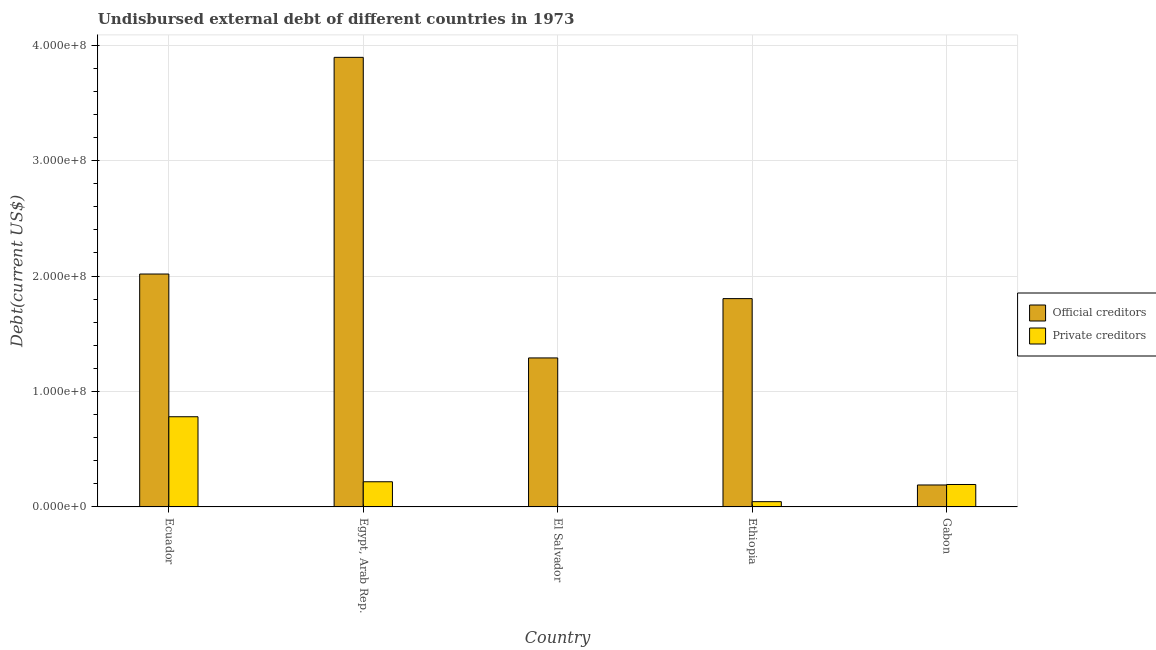How many different coloured bars are there?
Keep it short and to the point. 2. How many groups of bars are there?
Provide a short and direct response. 5. Are the number of bars per tick equal to the number of legend labels?
Your answer should be compact. Yes. Are the number of bars on each tick of the X-axis equal?
Offer a very short reply. Yes. How many bars are there on the 1st tick from the left?
Provide a succinct answer. 2. What is the label of the 2nd group of bars from the left?
Ensure brevity in your answer.  Egypt, Arab Rep. In how many cases, is the number of bars for a given country not equal to the number of legend labels?
Your response must be concise. 0. What is the undisbursed external debt of official creditors in Ecuador?
Provide a succinct answer. 2.02e+08. Across all countries, what is the maximum undisbursed external debt of official creditors?
Ensure brevity in your answer.  3.89e+08. In which country was the undisbursed external debt of official creditors maximum?
Your response must be concise. Egypt, Arab Rep. In which country was the undisbursed external debt of official creditors minimum?
Ensure brevity in your answer.  Gabon. What is the total undisbursed external debt of private creditors in the graph?
Ensure brevity in your answer.  1.24e+08. What is the difference between the undisbursed external debt of official creditors in Ecuador and that in Ethiopia?
Provide a short and direct response. 2.13e+07. What is the difference between the undisbursed external debt of private creditors in El Salvador and the undisbursed external debt of official creditors in Ethiopia?
Provide a succinct answer. -1.80e+08. What is the average undisbursed external debt of private creditors per country?
Provide a short and direct response. 2.48e+07. What is the difference between the undisbursed external debt of official creditors and undisbursed external debt of private creditors in Egypt, Arab Rep.?
Your response must be concise. 3.68e+08. What is the ratio of the undisbursed external debt of official creditors in Ecuador to that in Egypt, Arab Rep.?
Your response must be concise. 0.52. Is the undisbursed external debt of private creditors in Ecuador less than that in El Salvador?
Make the answer very short. No. Is the difference between the undisbursed external debt of official creditors in Ecuador and El Salvador greater than the difference between the undisbursed external debt of private creditors in Ecuador and El Salvador?
Your response must be concise. No. What is the difference between the highest and the second highest undisbursed external debt of private creditors?
Your response must be concise. 5.63e+07. What is the difference between the highest and the lowest undisbursed external debt of official creditors?
Offer a very short reply. 3.70e+08. Is the sum of the undisbursed external debt of official creditors in Egypt, Arab Rep. and Ethiopia greater than the maximum undisbursed external debt of private creditors across all countries?
Ensure brevity in your answer.  Yes. What does the 1st bar from the left in Egypt, Arab Rep. represents?
Your answer should be very brief. Official creditors. What does the 2nd bar from the right in Egypt, Arab Rep. represents?
Provide a short and direct response. Official creditors. Are all the bars in the graph horizontal?
Keep it short and to the point. No. How many countries are there in the graph?
Make the answer very short. 5. What is the difference between two consecutive major ticks on the Y-axis?
Keep it short and to the point. 1.00e+08. Does the graph contain grids?
Your response must be concise. Yes. What is the title of the graph?
Your answer should be compact. Undisbursed external debt of different countries in 1973. Does "Import" appear as one of the legend labels in the graph?
Offer a very short reply. No. What is the label or title of the Y-axis?
Ensure brevity in your answer.  Debt(current US$). What is the Debt(current US$) of Official creditors in Ecuador?
Your answer should be compact. 2.02e+08. What is the Debt(current US$) in Private creditors in Ecuador?
Give a very brief answer. 7.81e+07. What is the Debt(current US$) in Official creditors in Egypt, Arab Rep.?
Provide a short and direct response. 3.89e+08. What is the Debt(current US$) in Private creditors in Egypt, Arab Rep.?
Provide a succinct answer. 2.18e+07. What is the Debt(current US$) in Official creditors in El Salvador?
Give a very brief answer. 1.29e+08. What is the Debt(current US$) of Private creditors in El Salvador?
Keep it short and to the point. 1.00e+05. What is the Debt(current US$) of Official creditors in Ethiopia?
Provide a short and direct response. 1.80e+08. What is the Debt(current US$) of Private creditors in Ethiopia?
Make the answer very short. 4.57e+06. What is the Debt(current US$) in Official creditors in Gabon?
Offer a very short reply. 1.90e+07. What is the Debt(current US$) in Private creditors in Gabon?
Provide a short and direct response. 1.94e+07. Across all countries, what is the maximum Debt(current US$) in Official creditors?
Give a very brief answer. 3.89e+08. Across all countries, what is the maximum Debt(current US$) in Private creditors?
Provide a short and direct response. 7.81e+07. Across all countries, what is the minimum Debt(current US$) of Official creditors?
Keep it short and to the point. 1.90e+07. Across all countries, what is the minimum Debt(current US$) in Private creditors?
Provide a short and direct response. 1.00e+05. What is the total Debt(current US$) in Official creditors in the graph?
Your response must be concise. 9.20e+08. What is the total Debt(current US$) in Private creditors in the graph?
Make the answer very short. 1.24e+08. What is the difference between the Debt(current US$) in Official creditors in Ecuador and that in Egypt, Arab Rep.?
Provide a short and direct response. -1.88e+08. What is the difference between the Debt(current US$) in Private creditors in Ecuador and that in Egypt, Arab Rep.?
Keep it short and to the point. 5.63e+07. What is the difference between the Debt(current US$) in Official creditors in Ecuador and that in El Salvador?
Provide a succinct answer. 7.27e+07. What is the difference between the Debt(current US$) of Private creditors in Ecuador and that in El Salvador?
Your response must be concise. 7.80e+07. What is the difference between the Debt(current US$) of Official creditors in Ecuador and that in Ethiopia?
Keep it short and to the point. 2.13e+07. What is the difference between the Debt(current US$) in Private creditors in Ecuador and that in Ethiopia?
Ensure brevity in your answer.  7.35e+07. What is the difference between the Debt(current US$) of Official creditors in Ecuador and that in Gabon?
Your response must be concise. 1.83e+08. What is the difference between the Debt(current US$) of Private creditors in Ecuador and that in Gabon?
Offer a very short reply. 5.87e+07. What is the difference between the Debt(current US$) of Official creditors in Egypt, Arab Rep. and that in El Salvador?
Offer a terse response. 2.60e+08. What is the difference between the Debt(current US$) of Private creditors in Egypt, Arab Rep. and that in El Salvador?
Keep it short and to the point. 2.17e+07. What is the difference between the Debt(current US$) in Official creditors in Egypt, Arab Rep. and that in Ethiopia?
Make the answer very short. 2.09e+08. What is the difference between the Debt(current US$) in Private creditors in Egypt, Arab Rep. and that in Ethiopia?
Offer a terse response. 1.72e+07. What is the difference between the Debt(current US$) of Official creditors in Egypt, Arab Rep. and that in Gabon?
Your answer should be very brief. 3.70e+08. What is the difference between the Debt(current US$) of Private creditors in Egypt, Arab Rep. and that in Gabon?
Make the answer very short. 2.36e+06. What is the difference between the Debt(current US$) of Official creditors in El Salvador and that in Ethiopia?
Offer a very short reply. -5.14e+07. What is the difference between the Debt(current US$) in Private creditors in El Salvador and that in Ethiopia?
Your answer should be compact. -4.47e+06. What is the difference between the Debt(current US$) of Official creditors in El Salvador and that in Gabon?
Offer a very short reply. 1.10e+08. What is the difference between the Debt(current US$) of Private creditors in El Salvador and that in Gabon?
Provide a succinct answer. -1.93e+07. What is the difference between the Debt(current US$) in Official creditors in Ethiopia and that in Gabon?
Provide a succinct answer. 1.61e+08. What is the difference between the Debt(current US$) in Private creditors in Ethiopia and that in Gabon?
Give a very brief answer. -1.49e+07. What is the difference between the Debt(current US$) of Official creditors in Ecuador and the Debt(current US$) of Private creditors in Egypt, Arab Rep.?
Ensure brevity in your answer.  1.80e+08. What is the difference between the Debt(current US$) in Official creditors in Ecuador and the Debt(current US$) in Private creditors in El Salvador?
Offer a terse response. 2.02e+08. What is the difference between the Debt(current US$) of Official creditors in Ecuador and the Debt(current US$) of Private creditors in Ethiopia?
Offer a very short reply. 1.97e+08. What is the difference between the Debt(current US$) in Official creditors in Ecuador and the Debt(current US$) in Private creditors in Gabon?
Give a very brief answer. 1.82e+08. What is the difference between the Debt(current US$) in Official creditors in Egypt, Arab Rep. and the Debt(current US$) in Private creditors in El Salvador?
Offer a very short reply. 3.89e+08. What is the difference between the Debt(current US$) in Official creditors in Egypt, Arab Rep. and the Debt(current US$) in Private creditors in Ethiopia?
Provide a succinct answer. 3.85e+08. What is the difference between the Debt(current US$) of Official creditors in Egypt, Arab Rep. and the Debt(current US$) of Private creditors in Gabon?
Offer a terse response. 3.70e+08. What is the difference between the Debt(current US$) in Official creditors in El Salvador and the Debt(current US$) in Private creditors in Ethiopia?
Your response must be concise. 1.24e+08. What is the difference between the Debt(current US$) in Official creditors in El Salvador and the Debt(current US$) in Private creditors in Gabon?
Provide a short and direct response. 1.10e+08. What is the difference between the Debt(current US$) in Official creditors in Ethiopia and the Debt(current US$) in Private creditors in Gabon?
Keep it short and to the point. 1.61e+08. What is the average Debt(current US$) in Official creditors per country?
Your answer should be compact. 1.84e+08. What is the average Debt(current US$) in Private creditors per country?
Provide a short and direct response. 2.48e+07. What is the difference between the Debt(current US$) of Official creditors and Debt(current US$) of Private creditors in Ecuador?
Your response must be concise. 1.24e+08. What is the difference between the Debt(current US$) in Official creditors and Debt(current US$) in Private creditors in Egypt, Arab Rep.?
Your answer should be compact. 3.68e+08. What is the difference between the Debt(current US$) in Official creditors and Debt(current US$) in Private creditors in El Salvador?
Your response must be concise. 1.29e+08. What is the difference between the Debt(current US$) in Official creditors and Debt(current US$) in Private creditors in Ethiopia?
Provide a succinct answer. 1.76e+08. What is the difference between the Debt(current US$) in Official creditors and Debt(current US$) in Private creditors in Gabon?
Keep it short and to the point. -4.22e+05. What is the ratio of the Debt(current US$) of Official creditors in Ecuador to that in Egypt, Arab Rep.?
Give a very brief answer. 0.52. What is the ratio of the Debt(current US$) in Private creditors in Ecuador to that in Egypt, Arab Rep.?
Your answer should be very brief. 3.58. What is the ratio of the Debt(current US$) of Official creditors in Ecuador to that in El Salvador?
Keep it short and to the point. 1.56. What is the ratio of the Debt(current US$) in Private creditors in Ecuador to that in El Salvador?
Ensure brevity in your answer.  781.1. What is the ratio of the Debt(current US$) in Official creditors in Ecuador to that in Ethiopia?
Your answer should be very brief. 1.12. What is the ratio of the Debt(current US$) of Private creditors in Ecuador to that in Ethiopia?
Ensure brevity in your answer.  17.1. What is the ratio of the Debt(current US$) in Official creditors in Ecuador to that in Gabon?
Make the answer very short. 10.61. What is the ratio of the Debt(current US$) in Private creditors in Ecuador to that in Gabon?
Your answer should be very brief. 4.02. What is the ratio of the Debt(current US$) in Official creditors in Egypt, Arab Rep. to that in El Salvador?
Provide a succinct answer. 3.02. What is the ratio of the Debt(current US$) in Private creditors in Egypt, Arab Rep. to that in El Salvador?
Provide a succinct answer. 218. What is the ratio of the Debt(current US$) in Official creditors in Egypt, Arab Rep. to that in Ethiopia?
Your answer should be very brief. 2.16. What is the ratio of the Debt(current US$) of Private creditors in Egypt, Arab Rep. to that in Ethiopia?
Provide a short and direct response. 4.77. What is the ratio of the Debt(current US$) in Official creditors in Egypt, Arab Rep. to that in Gabon?
Provide a succinct answer. 20.48. What is the ratio of the Debt(current US$) in Private creditors in Egypt, Arab Rep. to that in Gabon?
Your response must be concise. 1.12. What is the ratio of the Debt(current US$) of Official creditors in El Salvador to that in Ethiopia?
Provide a succinct answer. 0.72. What is the ratio of the Debt(current US$) in Private creditors in El Salvador to that in Ethiopia?
Give a very brief answer. 0.02. What is the ratio of the Debt(current US$) of Official creditors in El Salvador to that in Gabon?
Provide a short and direct response. 6.79. What is the ratio of the Debt(current US$) in Private creditors in El Salvador to that in Gabon?
Your answer should be very brief. 0.01. What is the ratio of the Debt(current US$) of Official creditors in Ethiopia to that in Gabon?
Make the answer very short. 9.49. What is the ratio of the Debt(current US$) of Private creditors in Ethiopia to that in Gabon?
Your response must be concise. 0.23. What is the difference between the highest and the second highest Debt(current US$) in Official creditors?
Offer a terse response. 1.88e+08. What is the difference between the highest and the second highest Debt(current US$) of Private creditors?
Provide a short and direct response. 5.63e+07. What is the difference between the highest and the lowest Debt(current US$) in Official creditors?
Offer a very short reply. 3.70e+08. What is the difference between the highest and the lowest Debt(current US$) in Private creditors?
Offer a very short reply. 7.80e+07. 